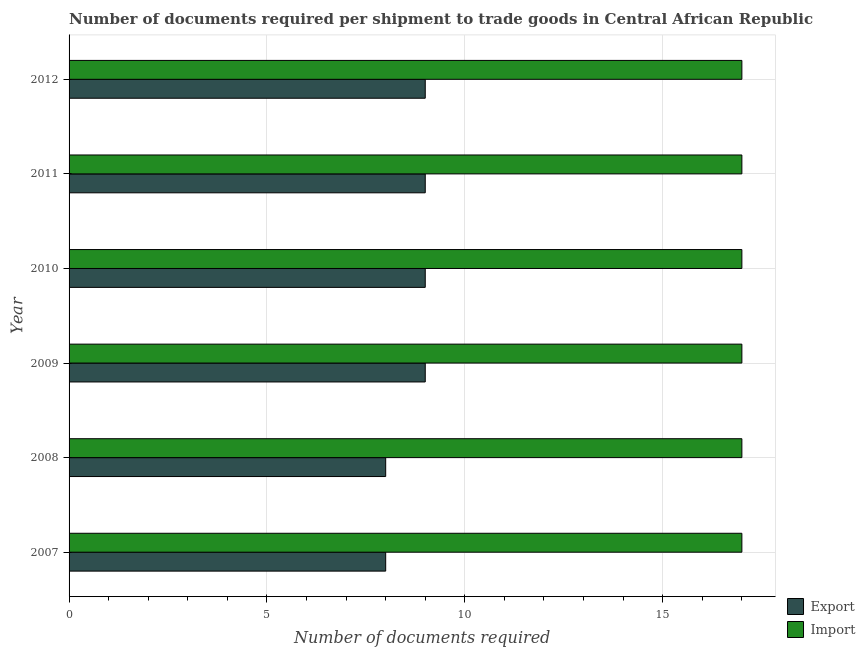How many different coloured bars are there?
Offer a terse response. 2. Are the number of bars per tick equal to the number of legend labels?
Your response must be concise. Yes. How many bars are there on the 5th tick from the top?
Keep it short and to the point. 2. How many bars are there on the 5th tick from the bottom?
Give a very brief answer. 2. What is the label of the 5th group of bars from the top?
Offer a very short reply. 2008. In how many cases, is the number of bars for a given year not equal to the number of legend labels?
Keep it short and to the point. 0. What is the number of documents required to export goods in 2010?
Your response must be concise. 9. Across all years, what is the maximum number of documents required to import goods?
Make the answer very short. 17. Across all years, what is the minimum number of documents required to import goods?
Keep it short and to the point. 17. In which year was the number of documents required to import goods minimum?
Ensure brevity in your answer.  2007. What is the total number of documents required to export goods in the graph?
Give a very brief answer. 52. What is the difference between the number of documents required to export goods in 2007 and that in 2009?
Provide a succinct answer. -1. What is the difference between the number of documents required to export goods in 2009 and the number of documents required to import goods in 2010?
Offer a terse response. -8. What is the average number of documents required to export goods per year?
Your answer should be compact. 8.67. In the year 2011, what is the difference between the number of documents required to export goods and number of documents required to import goods?
Your answer should be very brief. -8. In how many years, is the number of documents required to export goods greater than 5 ?
Your answer should be very brief. 6. What is the ratio of the number of documents required to import goods in 2007 to that in 2008?
Keep it short and to the point. 1. Is the difference between the number of documents required to export goods in 2010 and 2012 greater than the difference between the number of documents required to import goods in 2010 and 2012?
Your answer should be very brief. No. What is the difference between the highest and the second highest number of documents required to export goods?
Offer a terse response. 0. In how many years, is the number of documents required to import goods greater than the average number of documents required to import goods taken over all years?
Offer a very short reply. 0. What does the 1st bar from the top in 2012 represents?
Keep it short and to the point. Import. What does the 1st bar from the bottom in 2012 represents?
Your response must be concise. Export. Are all the bars in the graph horizontal?
Provide a succinct answer. Yes. What is the difference between two consecutive major ticks on the X-axis?
Give a very brief answer. 5. Are the values on the major ticks of X-axis written in scientific E-notation?
Ensure brevity in your answer.  No. Does the graph contain grids?
Make the answer very short. Yes. Where does the legend appear in the graph?
Provide a short and direct response. Bottom right. How many legend labels are there?
Your answer should be compact. 2. How are the legend labels stacked?
Your answer should be compact. Vertical. What is the title of the graph?
Offer a terse response. Number of documents required per shipment to trade goods in Central African Republic. What is the label or title of the X-axis?
Give a very brief answer. Number of documents required. What is the Number of documents required in Export in 2007?
Your answer should be very brief. 8. What is the Number of documents required in Import in 2007?
Provide a succinct answer. 17. What is the Number of documents required of Export in 2008?
Provide a succinct answer. 8. What is the Number of documents required of Import in 2010?
Provide a succinct answer. 17. What is the Number of documents required in Export in 2011?
Your answer should be compact. 9. What is the Number of documents required in Import in 2011?
Provide a short and direct response. 17. What is the Number of documents required in Import in 2012?
Ensure brevity in your answer.  17. What is the total Number of documents required of Export in the graph?
Your answer should be compact. 52. What is the total Number of documents required of Import in the graph?
Your response must be concise. 102. What is the difference between the Number of documents required in Export in 2007 and that in 2010?
Ensure brevity in your answer.  -1. What is the difference between the Number of documents required in Import in 2007 and that in 2011?
Your answer should be very brief. 0. What is the difference between the Number of documents required of Import in 2007 and that in 2012?
Give a very brief answer. 0. What is the difference between the Number of documents required in Export in 2008 and that in 2009?
Offer a terse response. -1. What is the difference between the Number of documents required of Export in 2008 and that in 2010?
Your answer should be very brief. -1. What is the difference between the Number of documents required of Import in 2008 and that in 2010?
Your answer should be compact. 0. What is the difference between the Number of documents required of Import in 2008 and that in 2011?
Ensure brevity in your answer.  0. What is the difference between the Number of documents required of Import in 2008 and that in 2012?
Offer a terse response. 0. What is the difference between the Number of documents required in Import in 2009 and that in 2011?
Provide a succinct answer. 0. What is the difference between the Number of documents required of Export in 2009 and that in 2012?
Ensure brevity in your answer.  0. What is the difference between the Number of documents required in Import in 2009 and that in 2012?
Provide a short and direct response. 0. What is the difference between the Number of documents required in Export in 2010 and that in 2011?
Keep it short and to the point. 0. What is the difference between the Number of documents required in Import in 2010 and that in 2012?
Provide a succinct answer. 0. What is the difference between the Number of documents required of Import in 2011 and that in 2012?
Provide a succinct answer. 0. What is the difference between the Number of documents required of Export in 2007 and the Number of documents required of Import in 2008?
Offer a terse response. -9. What is the difference between the Number of documents required of Export in 2007 and the Number of documents required of Import in 2009?
Ensure brevity in your answer.  -9. What is the difference between the Number of documents required in Export in 2007 and the Number of documents required in Import in 2012?
Provide a succinct answer. -9. What is the difference between the Number of documents required of Export in 2008 and the Number of documents required of Import in 2009?
Offer a very short reply. -9. What is the difference between the Number of documents required of Export in 2008 and the Number of documents required of Import in 2010?
Your response must be concise. -9. What is the difference between the Number of documents required in Export in 2008 and the Number of documents required in Import in 2012?
Make the answer very short. -9. What is the difference between the Number of documents required of Export in 2010 and the Number of documents required of Import in 2011?
Your response must be concise. -8. What is the difference between the Number of documents required in Export in 2011 and the Number of documents required in Import in 2012?
Ensure brevity in your answer.  -8. What is the average Number of documents required in Export per year?
Keep it short and to the point. 8.67. In the year 2007, what is the difference between the Number of documents required of Export and Number of documents required of Import?
Your answer should be very brief. -9. In the year 2008, what is the difference between the Number of documents required of Export and Number of documents required of Import?
Your answer should be compact. -9. In the year 2010, what is the difference between the Number of documents required of Export and Number of documents required of Import?
Offer a terse response. -8. In the year 2011, what is the difference between the Number of documents required of Export and Number of documents required of Import?
Give a very brief answer. -8. What is the ratio of the Number of documents required of Export in 2007 to that in 2008?
Offer a very short reply. 1. What is the ratio of the Number of documents required in Import in 2007 to that in 2008?
Offer a terse response. 1. What is the ratio of the Number of documents required of Export in 2007 to that in 2009?
Your answer should be compact. 0.89. What is the ratio of the Number of documents required of Import in 2007 to that in 2009?
Give a very brief answer. 1. What is the ratio of the Number of documents required in Import in 2007 to that in 2010?
Offer a terse response. 1. What is the ratio of the Number of documents required in Export in 2007 to that in 2011?
Offer a very short reply. 0.89. What is the ratio of the Number of documents required in Export in 2007 to that in 2012?
Keep it short and to the point. 0.89. What is the ratio of the Number of documents required in Import in 2007 to that in 2012?
Provide a succinct answer. 1. What is the ratio of the Number of documents required of Import in 2008 to that in 2009?
Your answer should be very brief. 1. What is the ratio of the Number of documents required of Export in 2008 to that in 2010?
Give a very brief answer. 0.89. What is the ratio of the Number of documents required in Import in 2008 to that in 2010?
Your answer should be compact. 1. What is the ratio of the Number of documents required in Export in 2008 to that in 2011?
Offer a very short reply. 0.89. What is the ratio of the Number of documents required in Import in 2008 to that in 2011?
Your response must be concise. 1. What is the ratio of the Number of documents required of Import in 2008 to that in 2012?
Ensure brevity in your answer.  1. What is the ratio of the Number of documents required in Export in 2009 to that in 2010?
Give a very brief answer. 1. What is the ratio of the Number of documents required in Export in 2009 to that in 2011?
Give a very brief answer. 1. What is the ratio of the Number of documents required in Export in 2009 to that in 2012?
Offer a terse response. 1. What is the ratio of the Number of documents required in Export in 2010 to that in 2011?
Your answer should be very brief. 1. What is the ratio of the Number of documents required of Import in 2010 to that in 2011?
Offer a very short reply. 1. What is the ratio of the Number of documents required of Export in 2011 to that in 2012?
Give a very brief answer. 1. What is the ratio of the Number of documents required in Import in 2011 to that in 2012?
Your answer should be compact. 1. What is the difference between the highest and the lowest Number of documents required in Import?
Your answer should be compact. 0. 